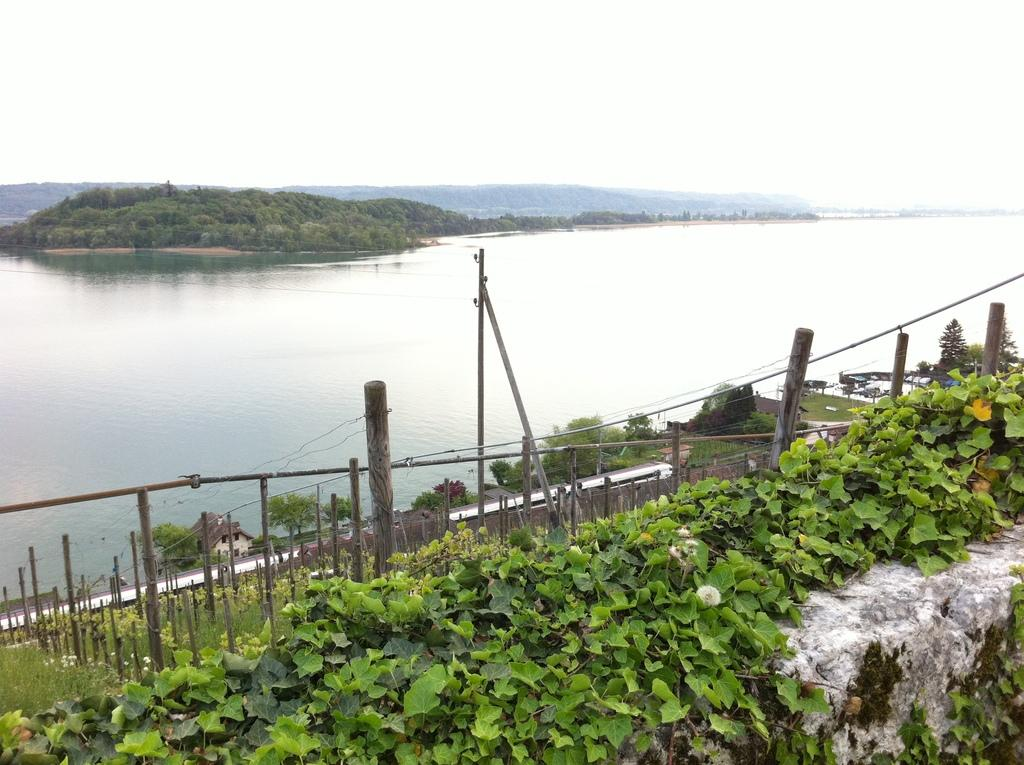What type of living organisms can be seen in the image? Plants and trees are visible in the image. What type of structures are present in the image? There are wooden poles in the image. What natural element is visible in the image? Water is visible in the image. What is visible in the background of the image? The sky is visible in the background of the image. Who is wearing the crown in the image? There is no crown present in the image. What type of birthday celebration is taking place in the image? There is no birthday celebration depicted in the image. 